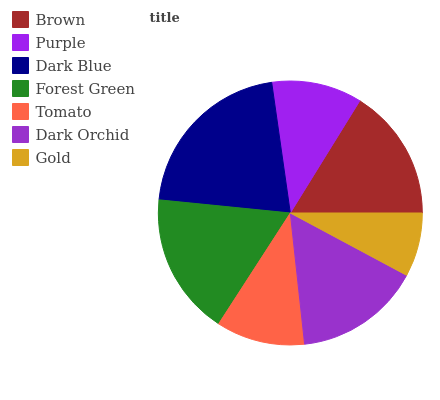Is Gold the minimum?
Answer yes or no. Yes. Is Dark Blue the maximum?
Answer yes or no. Yes. Is Purple the minimum?
Answer yes or no. No. Is Purple the maximum?
Answer yes or no. No. Is Brown greater than Purple?
Answer yes or no. Yes. Is Purple less than Brown?
Answer yes or no. Yes. Is Purple greater than Brown?
Answer yes or no. No. Is Brown less than Purple?
Answer yes or no. No. Is Dark Orchid the high median?
Answer yes or no. Yes. Is Dark Orchid the low median?
Answer yes or no. Yes. Is Brown the high median?
Answer yes or no. No. Is Purple the low median?
Answer yes or no. No. 